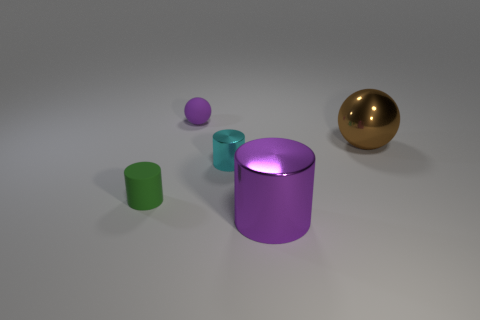What material is the ball that is the same color as the big shiny cylinder?
Provide a succinct answer. Rubber. There is a purple sphere that is the same size as the green rubber thing; what material is it?
Offer a terse response. Rubber. There is a ball that is on the left side of the large shiny cylinder; does it have the same color as the large metallic thing in front of the rubber cylinder?
Offer a terse response. Yes. Is there a cyan metal object of the same shape as the small green matte object?
Your answer should be compact. Yes. The object that is the same size as the brown sphere is what shape?
Offer a terse response. Cylinder. What number of large metallic balls have the same color as the tiny matte sphere?
Offer a terse response. 0. What size is the shiny thing on the left side of the purple metal object?
Provide a short and direct response. Small. How many other metallic cylinders have the same size as the cyan cylinder?
Your response must be concise. 0. What is the color of the sphere that is made of the same material as the large purple object?
Your answer should be compact. Brown. Are there fewer brown balls behind the brown metal thing than tiny gray metallic objects?
Give a very brief answer. No. 